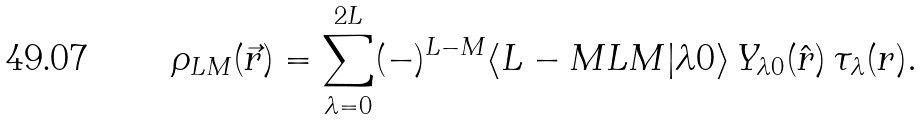Convert formula to latex. <formula><loc_0><loc_0><loc_500><loc_500>\rho _ { L M } ( \vec { r } ) = \sum _ { \lambda = 0 } ^ { 2 L } ( - ) ^ { L - M } \langle L - M L M | \lambda 0 \rangle \, Y _ { \lambda 0 } ( \hat { r } ) \, \tau _ { \lambda } ( r ) .</formula> 